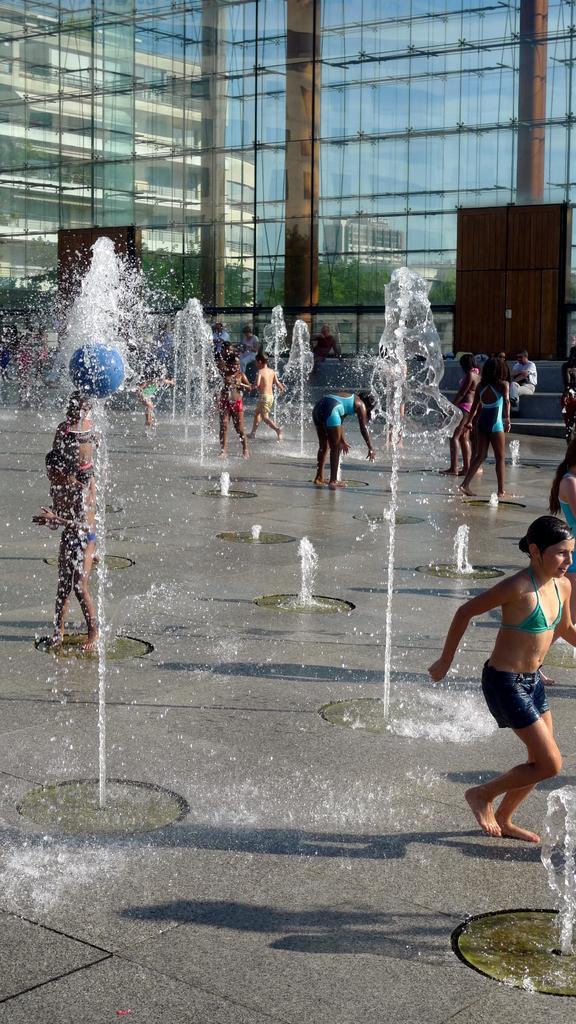In one or two sentences, can you explain what this image depicts? In this image I can see the ground, few fountains and few persons are standing on the ground. In the background I can see a huge glass and through the glass I can see few buildings and the sky. 